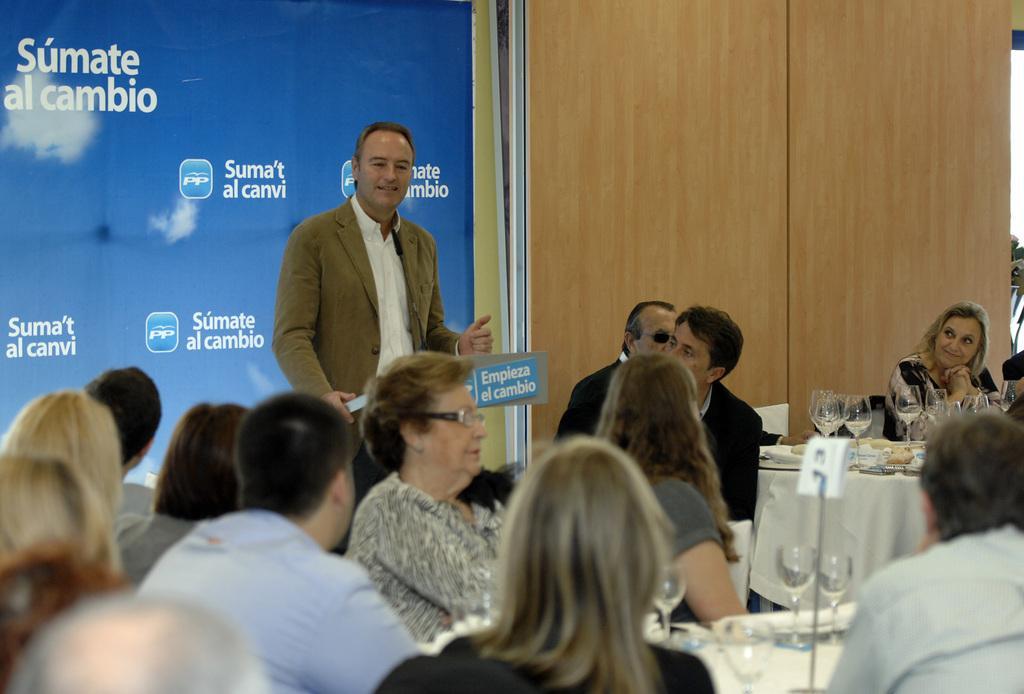How would you summarize this image in a sentence or two? In this image we can see a man standing. We can also see the people sitting. Image also consists of the tables which are covered with the clothes and on the tables we can see the glasses. In the background we can see the banner with the text. We can also see the wooden wall. 